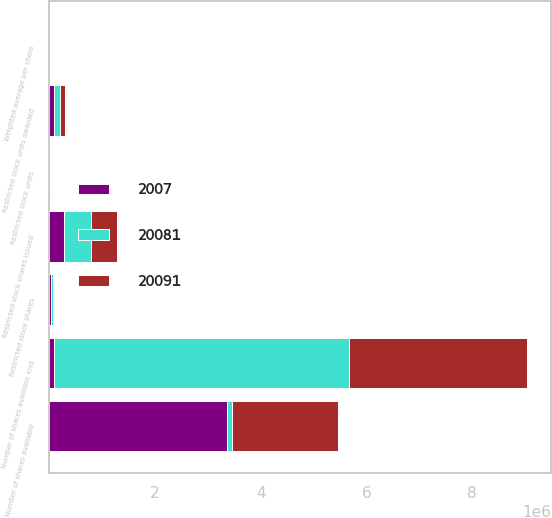<chart> <loc_0><loc_0><loc_500><loc_500><stacked_bar_chart><ecel><fcel>Number of shares available<fcel>Restricted stock shares issued<fcel>Restricted stock units awarded<fcel>Restricted stock shares<fcel>Restricted stock units<fcel>Number of shares available end<fcel>Weighted average per share<nl><fcel>20081<fcel>95900<fcel>516650<fcel>106200<fcel>38431<fcel>19700<fcel>5.578e+06<fcel>16.33<nl><fcel>2007<fcel>3.365e+06<fcel>287200<fcel>96200<fcel>42220<fcel>6800<fcel>95900<fcel>23.28<nl><fcel>20091<fcel>2.00915e+06<fcel>474100<fcel>95900<fcel>11600<fcel>4300<fcel>3.365e+06<fcel>30.54<nl></chart> 